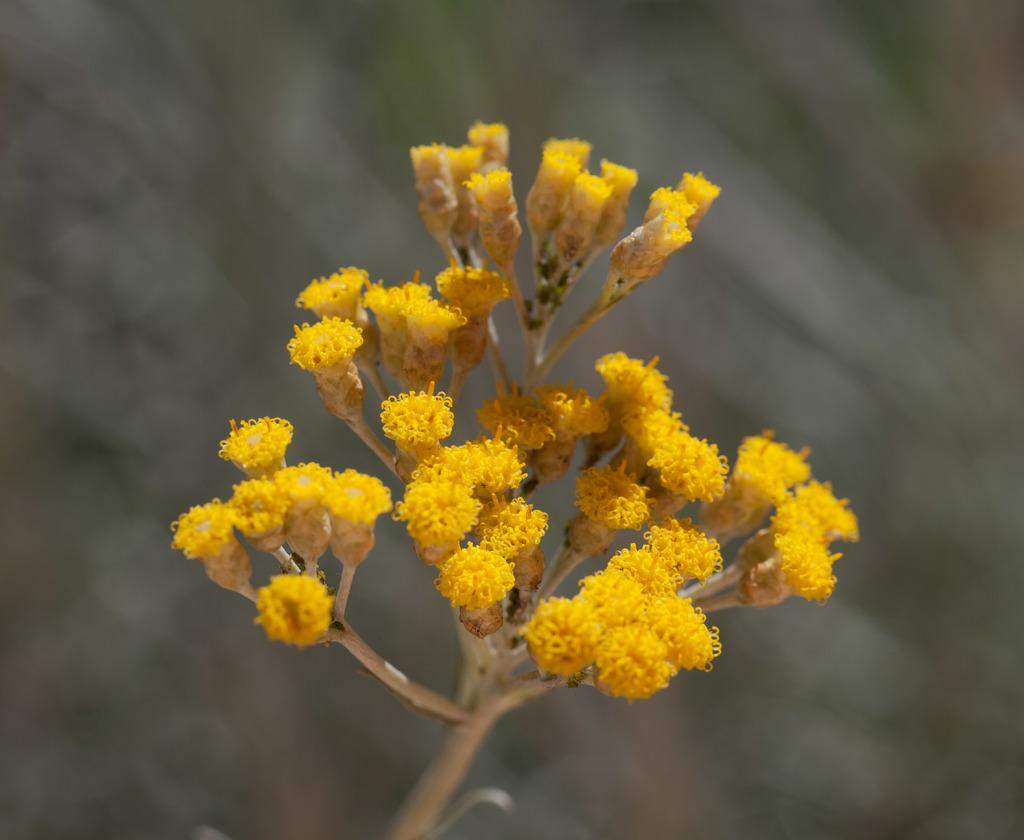What type of plant is visible in the image? The image features a plant with flowers. What color are the flowers on the plant? The flowers on the plant are yellow in color. What invention can be seen in the image related to the flowers? There is no invention related to the flowers visible in the image; it simply shows a plant with yellow flowers. How long does it take for the flowers to grow according to the receipt in the image? There is no receipt present in the image, and therefore no information about the flowers' growth rate can be determined. 